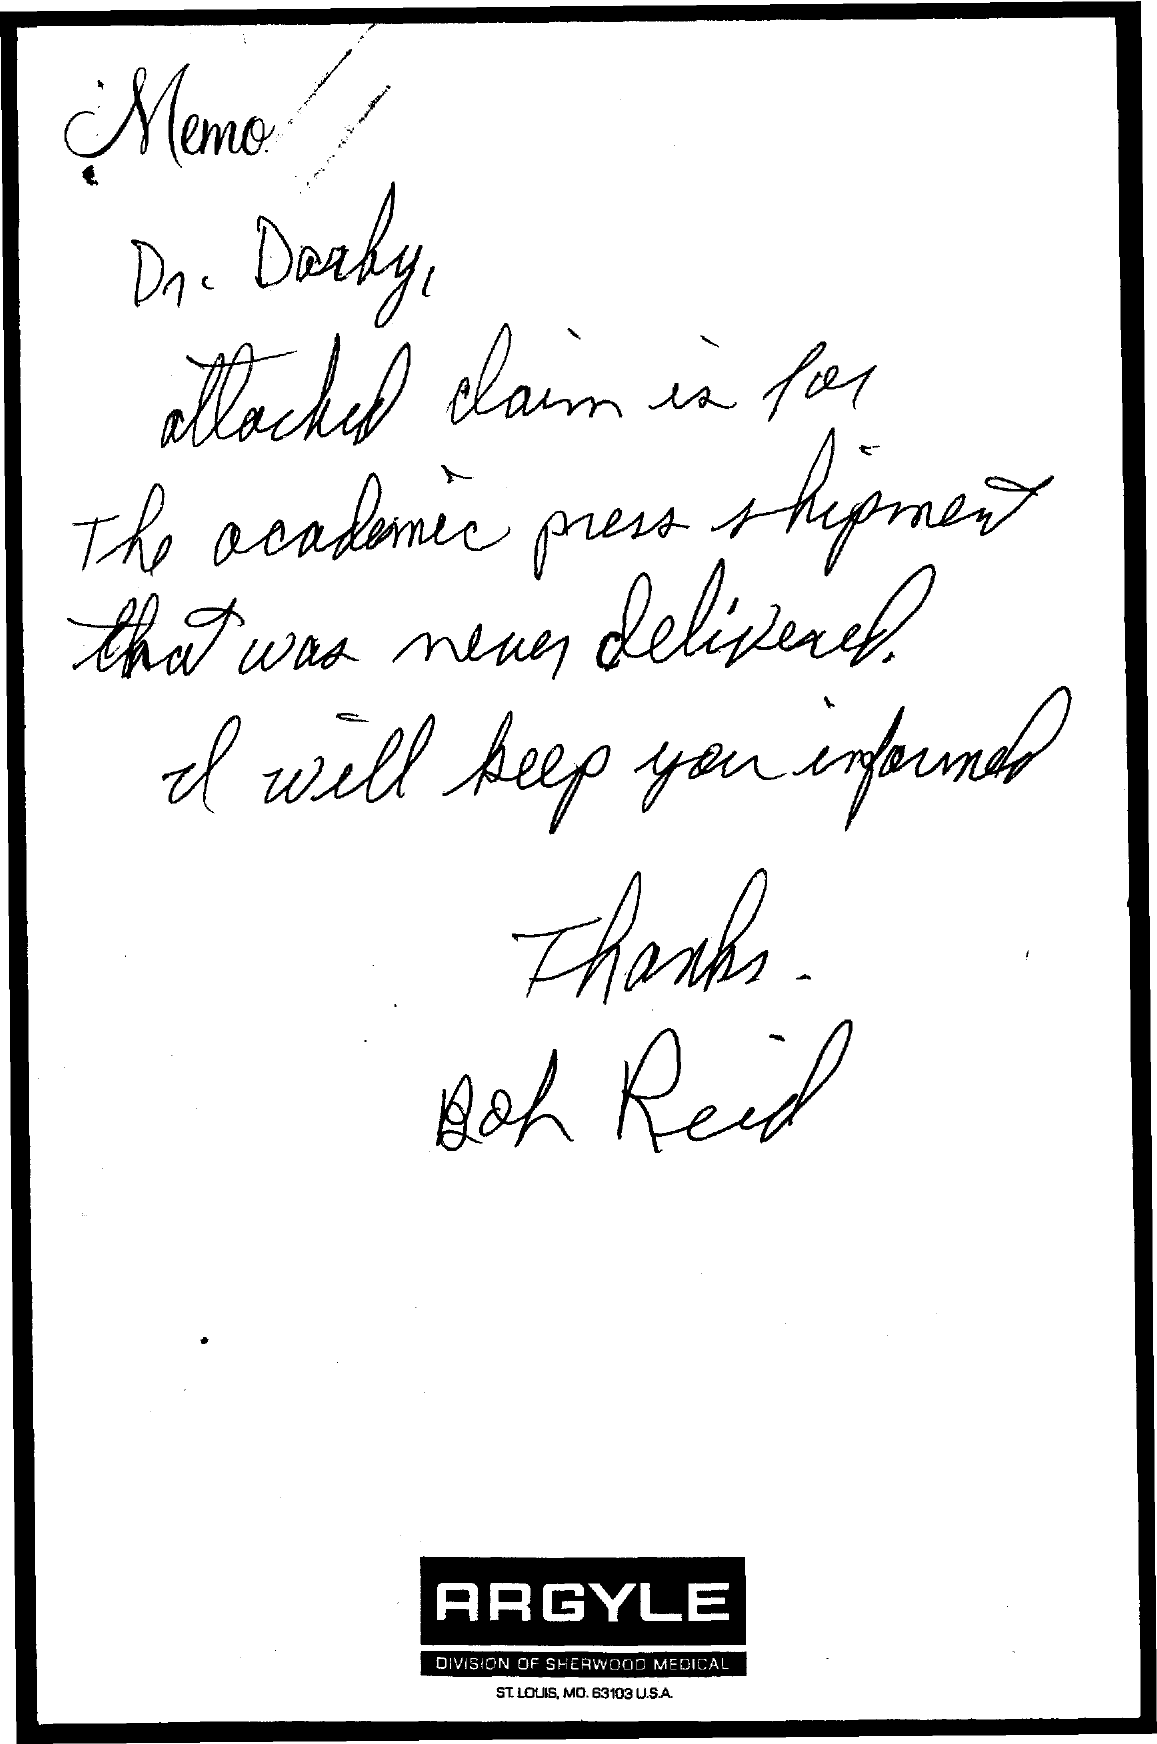List a handful of essential elements in this visual. The addressee of this memo is Dr. Darby. 